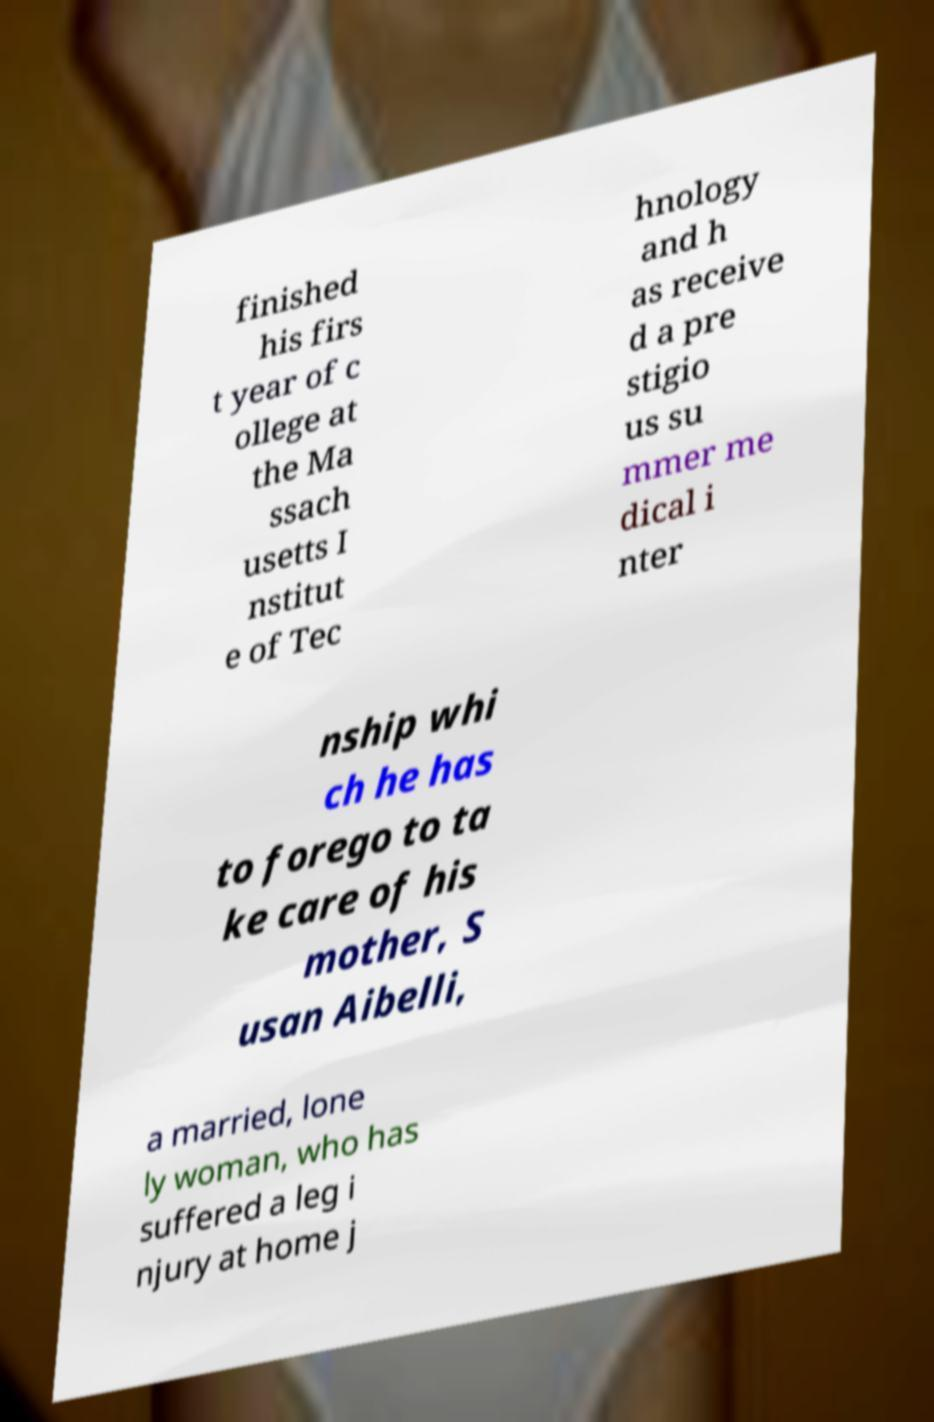I need the written content from this picture converted into text. Can you do that? finished his firs t year of c ollege at the Ma ssach usetts I nstitut e of Tec hnology and h as receive d a pre stigio us su mmer me dical i nter nship whi ch he has to forego to ta ke care of his mother, S usan Aibelli, a married, lone ly woman, who has suffered a leg i njury at home j 